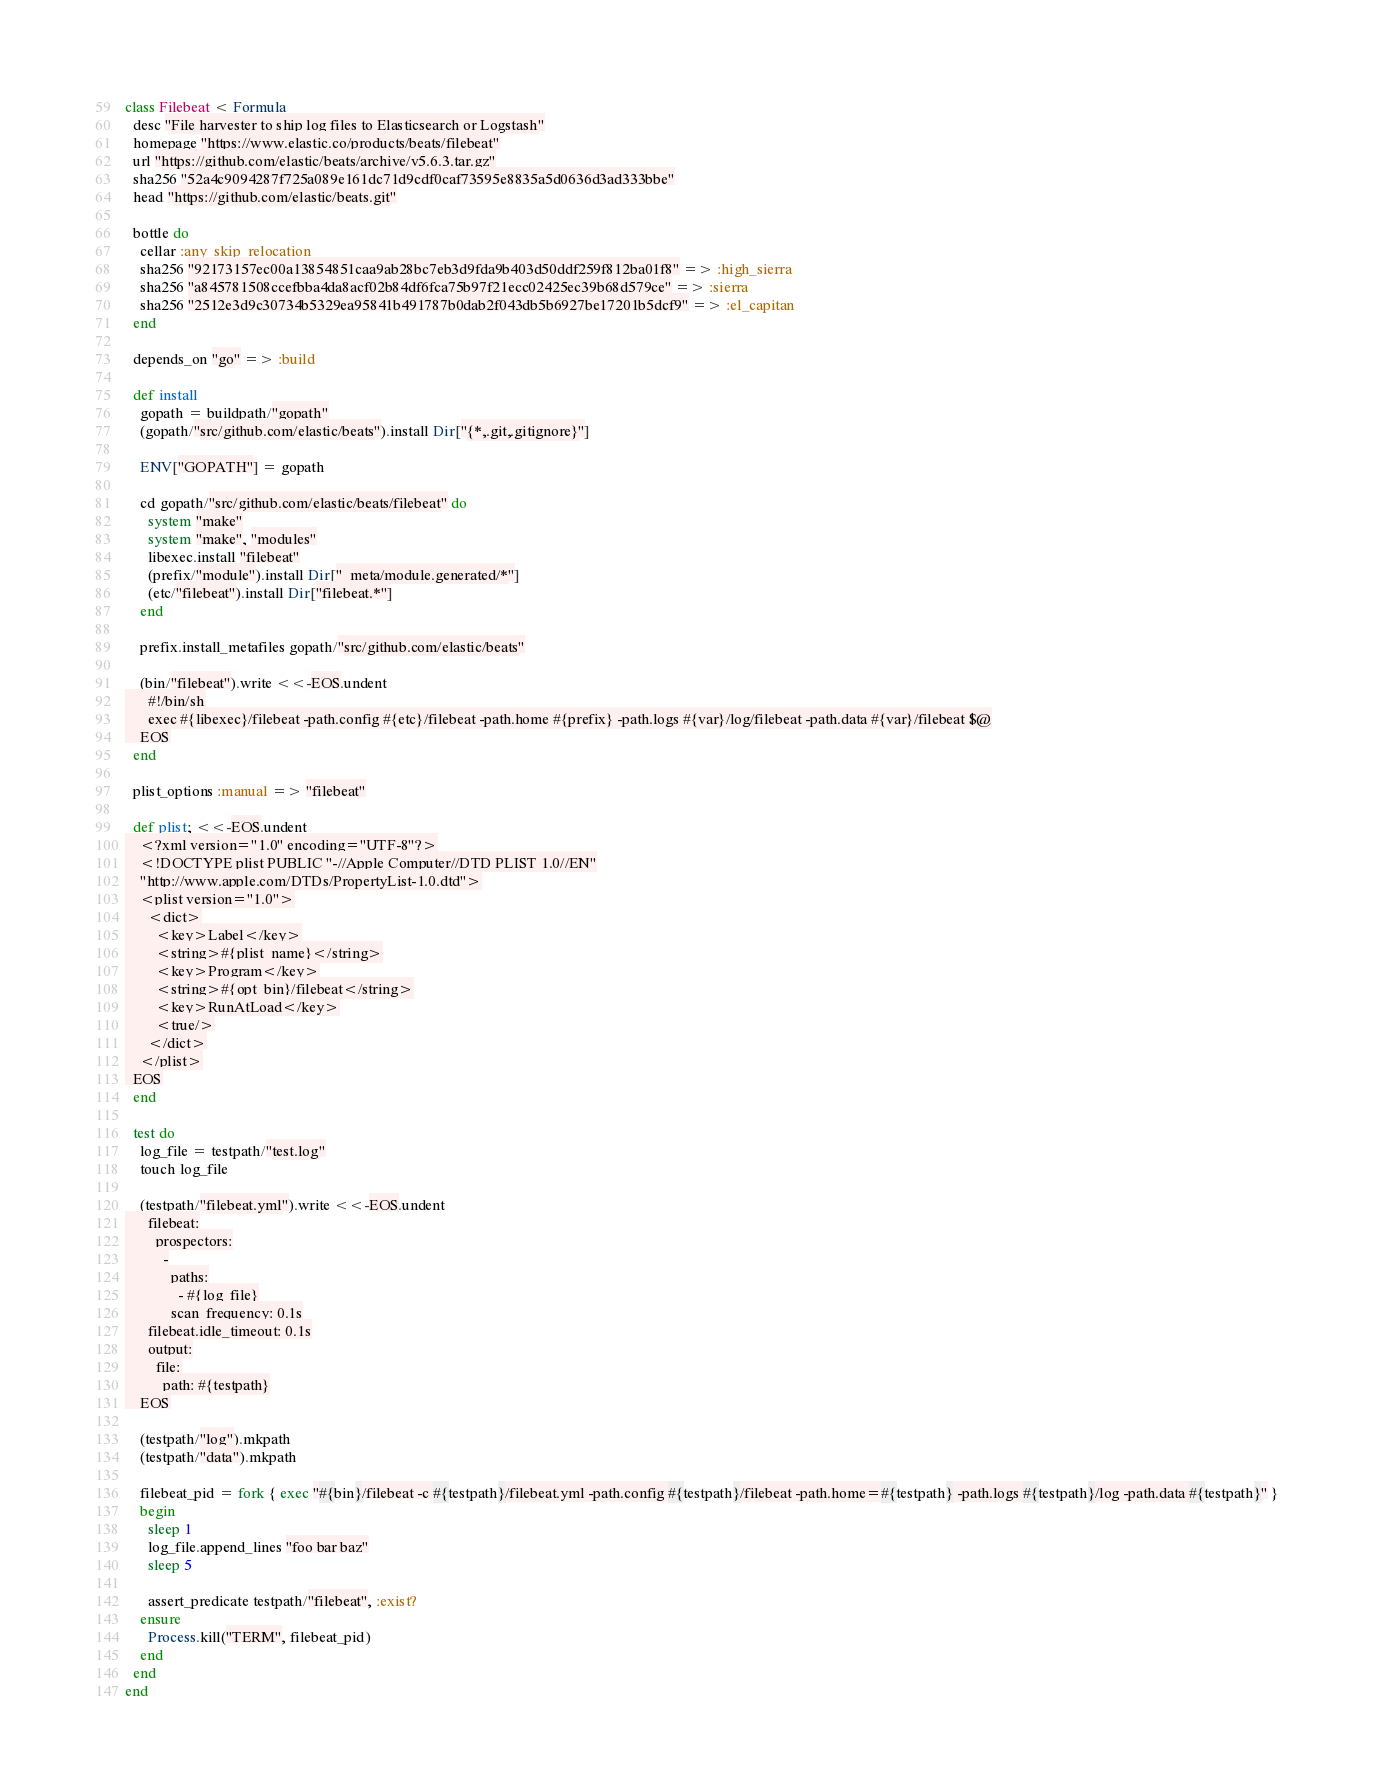<code> <loc_0><loc_0><loc_500><loc_500><_Ruby_>class Filebeat < Formula
  desc "File harvester to ship log files to Elasticsearch or Logstash"
  homepage "https://www.elastic.co/products/beats/filebeat"
  url "https://github.com/elastic/beats/archive/v5.6.3.tar.gz"
  sha256 "52a4c9094287f725a089e161dc71d9cdf0caf73595e8835a5d0636d3ad333bbe"
  head "https://github.com/elastic/beats.git"

  bottle do
    cellar :any_skip_relocation
    sha256 "92173157ec00a13854851caa9ab28bc7eb3d9fda9b403d50ddf259f812ba01f8" => :high_sierra
    sha256 "a845781508ccefbba4da8acf02b84df6fca75b97f21ecc02425ec39b68d579ce" => :sierra
    sha256 "2512e3d9c30734b5329ea95841b491787b0dab2f043db5b6927be17201b5dcf9" => :el_capitan
  end

  depends_on "go" => :build

  def install
    gopath = buildpath/"gopath"
    (gopath/"src/github.com/elastic/beats").install Dir["{*,.git,.gitignore}"]

    ENV["GOPATH"] = gopath

    cd gopath/"src/github.com/elastic/beats/filebeat" do
      system "make"
      system "make", "modules"
      libexec.install "filebeat"
      (prefix/"module").install Dir["_meta/module.generated/*"]
      (etc/"filebeat").install Dir["filebeat.*"]
    end

    prefix.install_metafiles gopath/"src/github.com/elastic/beats"

    (bin/"filebeat").write <<-EOS.undent
      #!/bin/sh
      exec #{libexec}/filebeat -path.config #{etc}/filebeat -path.home #{prefix} -path.logs #{var}/log/filebeat -path.data #{var}/filebeat $@
    EOS
  end

  plist_options :manual => "filebeat"

  def plist; <<-EOS.undent
    <?xml version="1.0" encoding="UTF-8"?>
    <!DOCTYPE plist PUBLIC "-//Apple Computer//DTD PLIST 1.0//EN"
    "http://www.apple.com/DTDs/PropertyList-1.0.dtd">
    <plist version="1.0">
      <dict>
        <key>Label</key>
        <string>#{plist_name}</string>
        <key>Program</key>
        <string>#{opt_bin}/filebeat</string>
        <key>RunAtLoad</key>
        <true/>
      </dict>
    </plist>
  EOS
  end

  test do
    log_file = testpath/"test.log"
    touch log_file

    (testpath/"filebeat.yml").write <<-EOS.undent
      filebeat:
        prospectors:
          -
            paths:
              - #{log_file}
            scan_frequency: 0.1s
      filebeat.idle_timeout: 0.1s
      output:
        file:
          path: #{testpath}
    EOS

    (testpath/"log").mkpath
    (testpath/"data").mkpath

    filebeat_pid = fork { exec "#{bin}/filebeat -c #{testpath}/filebeat.yml -path.config #{testpath}/filebeat -path.home=#{testpath} -path.logs #{testpath}/log -path.data #{testpath}" }
    begin
      sleep 1
      log_file.append_lines "foo bar baz"
      sleep 5

      assert_predicate testpath/"filebeat", :exist?
    ensure
      Process.kill("TERM", filebeat_pid)
    end
  end
end
</code> 